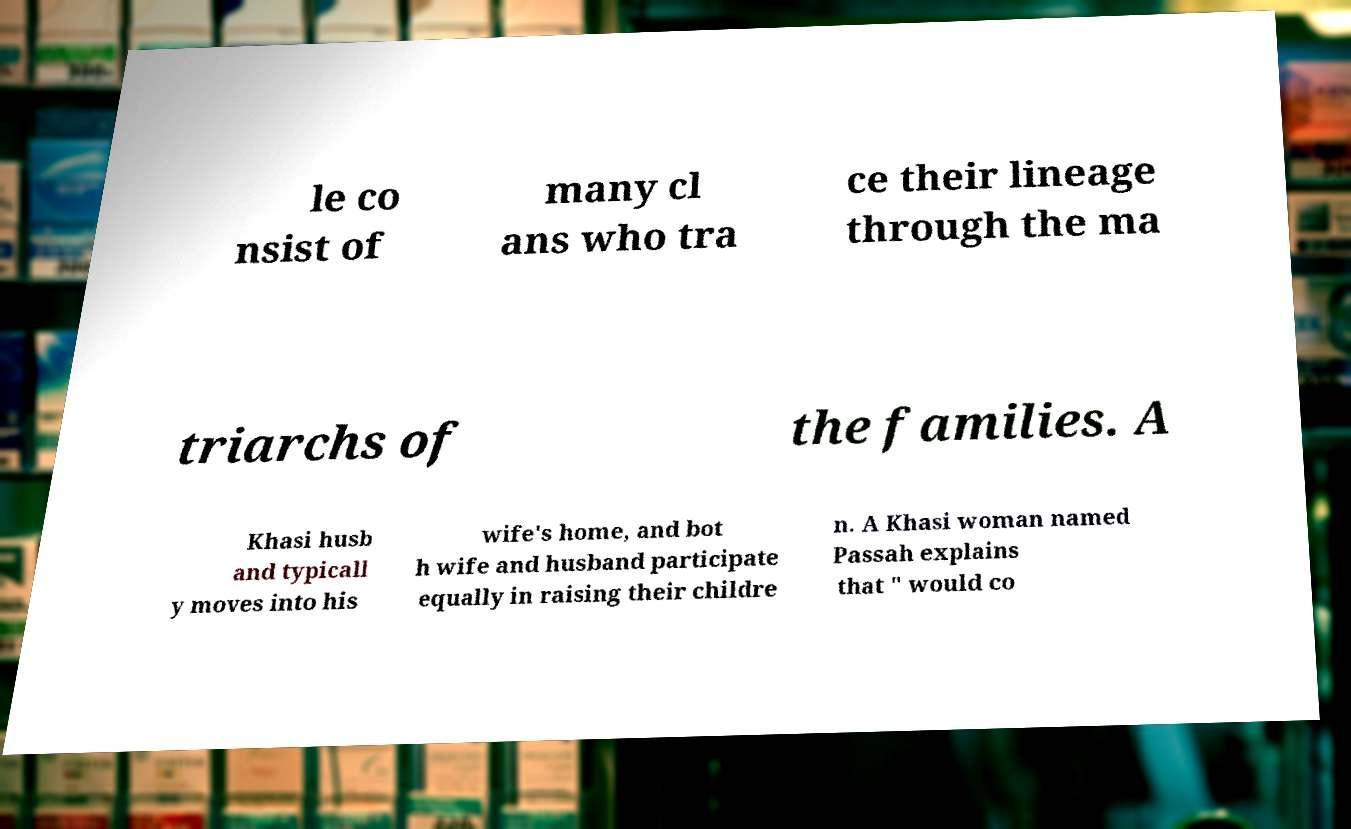Can you read and provide the text displayed in the image?This photo seems to have some interesting text. Can you extract and type it out for me? le co nsist of many cl ans who tra ce their lineage through the ma triarchs of the families. A Khasi husb and typicall y moves into his wife's home, and bot h wife and husband participate equally in raising their childre n. A Khasi woman named Passah explains that " would co 